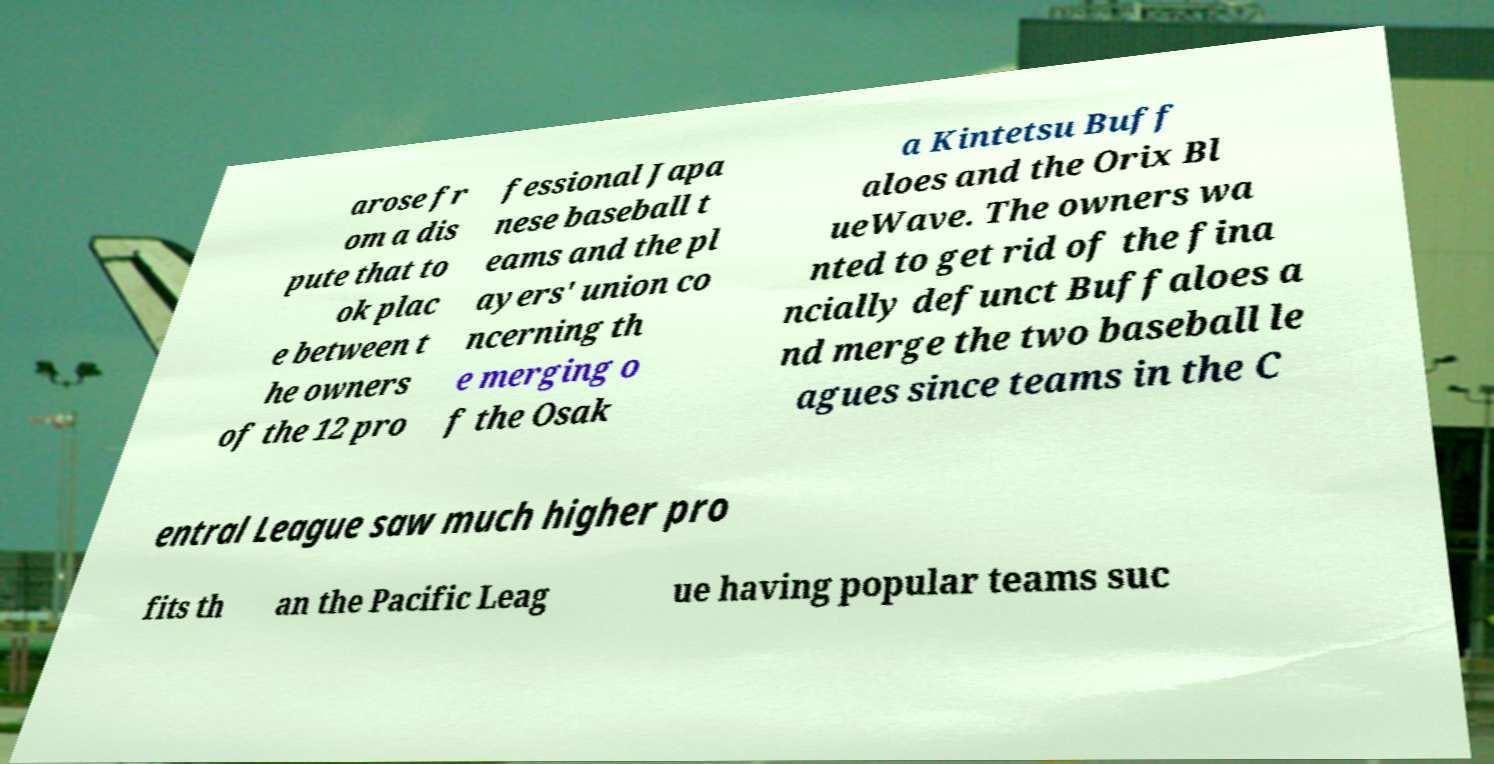I need the written content from this picture converted into text. Can you do that? arose fr om a dis pute that to ok plac e between t he owners of the 12 pro fessional Japa nese baseball t eams and the pl ayers' union co ncerning th e merging o f the Osak a Kintetsu Buff aloes and the Orix Bl ueWave. The owners wa nted to get rid of the fina ncially defunct Buffaloes a nd merge the two baseball le agues since teams in the C entral League saw much higher pro fits th an the Pacific Leag ue having popular teams suc 